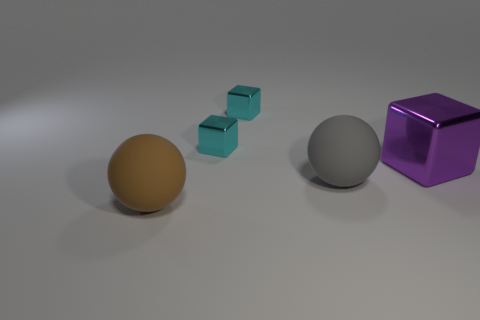Add 5 brown objects. How many objects exist? 10 Subtract all cubes. How many objects are left? 2 Add 3 large matte balls. How many large matte balls exist? 5 Subtract 0 blue spheres. How many objects are left? 5 Subtract all brown rubber things. Subtract all gray rubber objects. How many objects are left? 3 Add 2 large rubber things. How many large rubber things are left? 4 